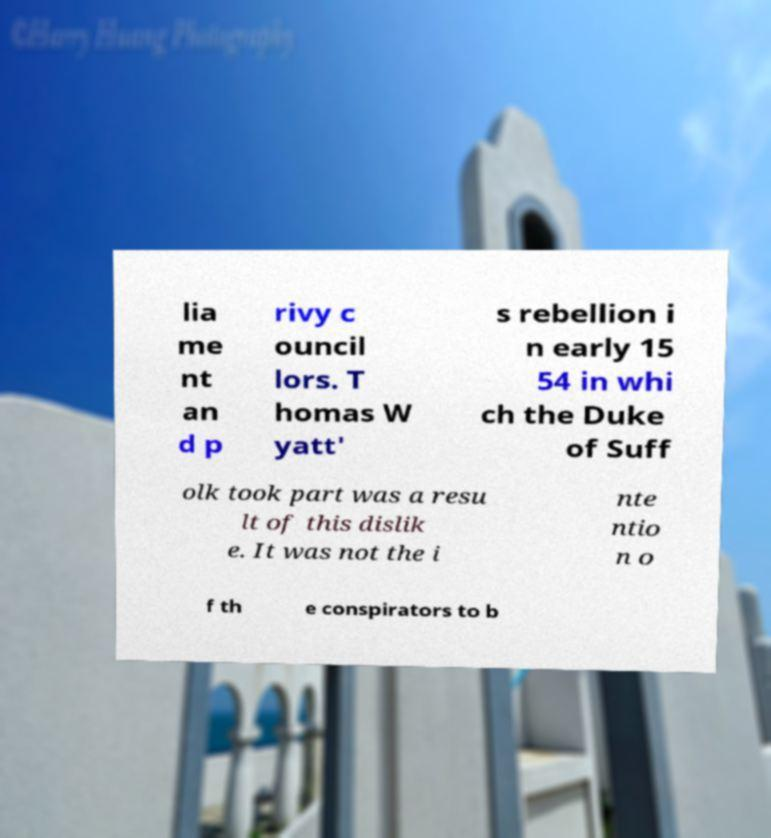Can you accurately transcribe the text from the provided image for me? lia me nt an d p rivy c ouncil lors. T homas W yatt' s rebellion i n early 15 54 in whi ch the Duke of Suff olk took part was a resu lt of this dislik e. It was not the i nte ntio n o f th e conspirators to b 